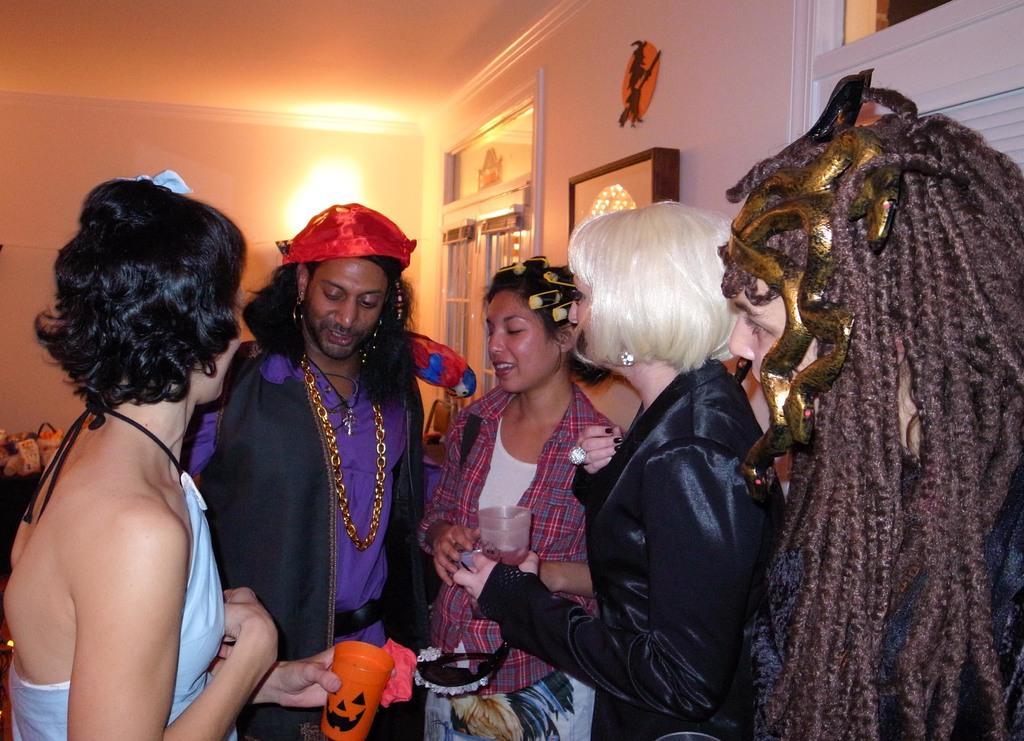In one or two sentences, can you explain what this image depicts? In this image, I can see five people standing and holding the objects. Behind these people, I can see a light and window. There is a photo frame and an object attached to the wall. 